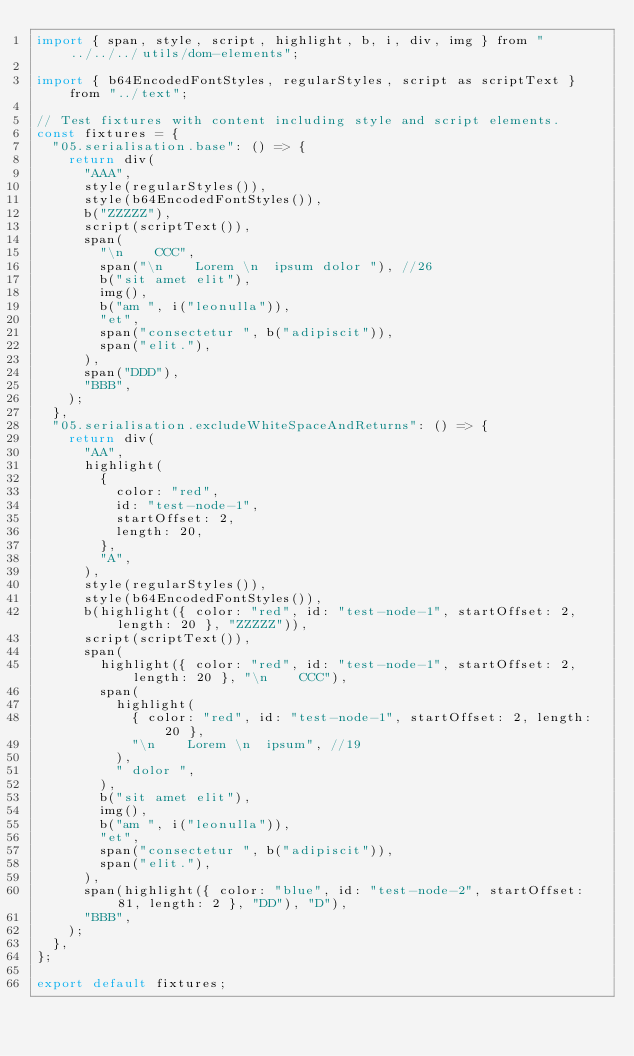<code> <loc_0><loc_0><loc_500><loc_500><_JavaScript_>import { span, style, script, highlight, b, i, div, img } from "../../../utils/dom-elements";

import { b64EncodedFontStyles, regularStyles, script as scriptText } from "../text";

// Test fixtures with content including style and script elements.
const fixtures = {
  "05.serialisation.base": () => {
    return div(
      "AAA",
      style(regularStyles()),
      style(b64EncodedFontStyles()),
      b("ZZZZZ"),
      script(scriptText()),
      span(
        "\n    CCC",
        span("\n    Lorem \n  ipsum dolor "), //26
        b("sit amet elit"),
        img(),
        b("am ", i("leonulla")),
        "et",
        span("consectetur ", b("adipiscit")),
        span("elit."),
      ),
      span("DDD"),
      "BBB",
    );
  },
  "05.serialisation.excludeWhiteSpaceAndReturns": () => {
    return div(
      "AA",
      highlight(
        {
          color: "red",
          id: "test-node-1",
          startOffset: 2,
          length: 20,
        },
        "A",
      ),
      style(regularStyles()),
      style(b64EncodedFontStyles()),
      b(highlight({ color: "red", id: "test-node-1", startOffset: 2, length: 20 }, "ZZZZZ")),
      script(scriptText()),
      span(
        highlight({ color: "red", id: "test-node-1", startOffset: 2, length: 20 }, "\n    CCC"),
        span(
          highlight(
            { color: "red", id: "test-node-1", startOffset: 2, length: 20 },
            "\n    Lorem \n  ipsum", //19
          ),
          " dolor ",
        ),
        b("sit amet elit"),
        img(),
        b("am ", i("leonulla")),
        "et",
        span("consectetur ", b("adipiscit")),
        span("elit."),
      ),
      span(highlight({ color: "blue", id: "test-node-2", startOffset: 81, length: 2 }, "DD"), "D"),
      "BBB",
    );
  },
};

export default fixtures;
</code> 